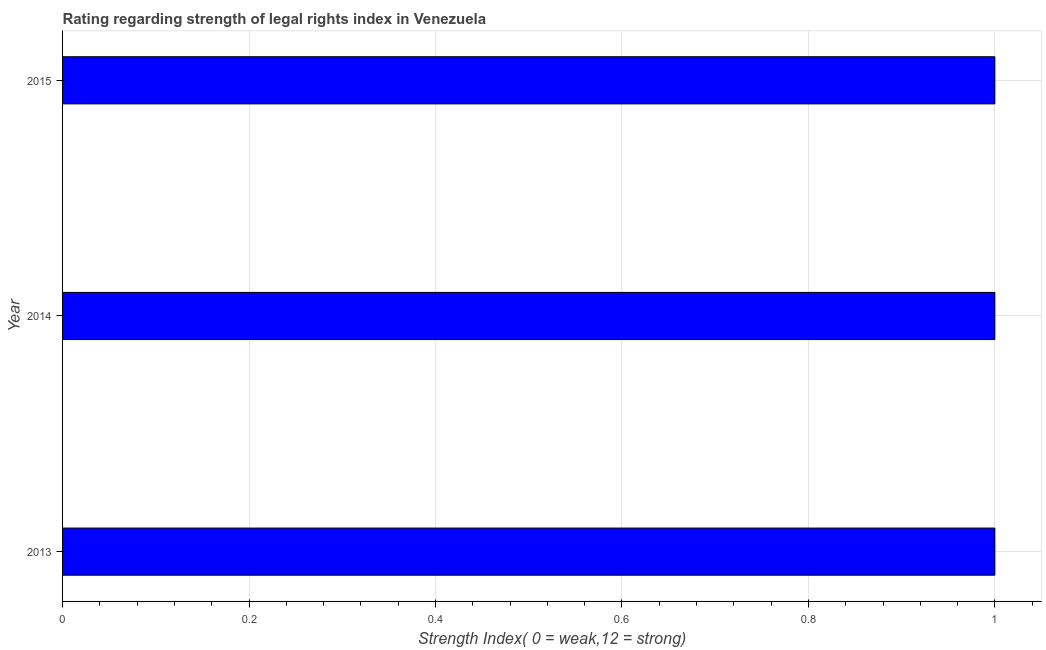What is the title of the graph?
Provide a short and direct response. Rating regarding strength of legal rights index in Venezuela. What is the label or title of the X-axis?
Your answer should be very brief. Strength Index( 0 = weak,12 = strong). Across all years, what is the minimum strength of legal rights index?
Provide a succinct answer. 1. What is the difference between the strength of legal rights index in 2014 and 2015?
Offer a very short reply. 0. What is the median strength of legal rights index?
Offer a very short reply. 1. In how many years, is the strength of legal rights index greater than 0.08 ?
Give a very brief answer. 3. What is the difference between the highest and the lowest strength of legal rights index?
Ensure brevity in your answer.  0. In how many years, is the strength of legal rights index greater than the average strength of legal rights index taken over all years?
Give a very brief answer. 0. Are all the bars in the graph horizontal?
Offer a terse response. Yes. How many years are there in the graph?
Offer a very short reply. 3. What is the difference between two consecutive major ticks on the X-axis?
Provide a short and direct response. 0.2. Are the values on the major ticks of X-axis written in scientific E-notation?
Your answer should be compact. No. What is the Strength Index( 0 = weak,12 = strong) of 2015?
Offer a very short reply. 1. What is the difference between the Strength Index( 0 = weak,12 = strong) in 2013 and 2015?
Your answer should be very brief. 0. What is the difference between the Strength Index( 0 = weak,12 = strong) in 2014 and 2015?
Keep it short and to the point. 0. What is the ratio of the Strength Index( 0 = weak,12 = strong) in 2013 to that in 2014?
Ensure brevity in your answer.  1. What is the ratio of the Strength Index( 0 = weak,12 = strong) in 2014 to that in 2015?
Ensure brevity in your answer.  1. 